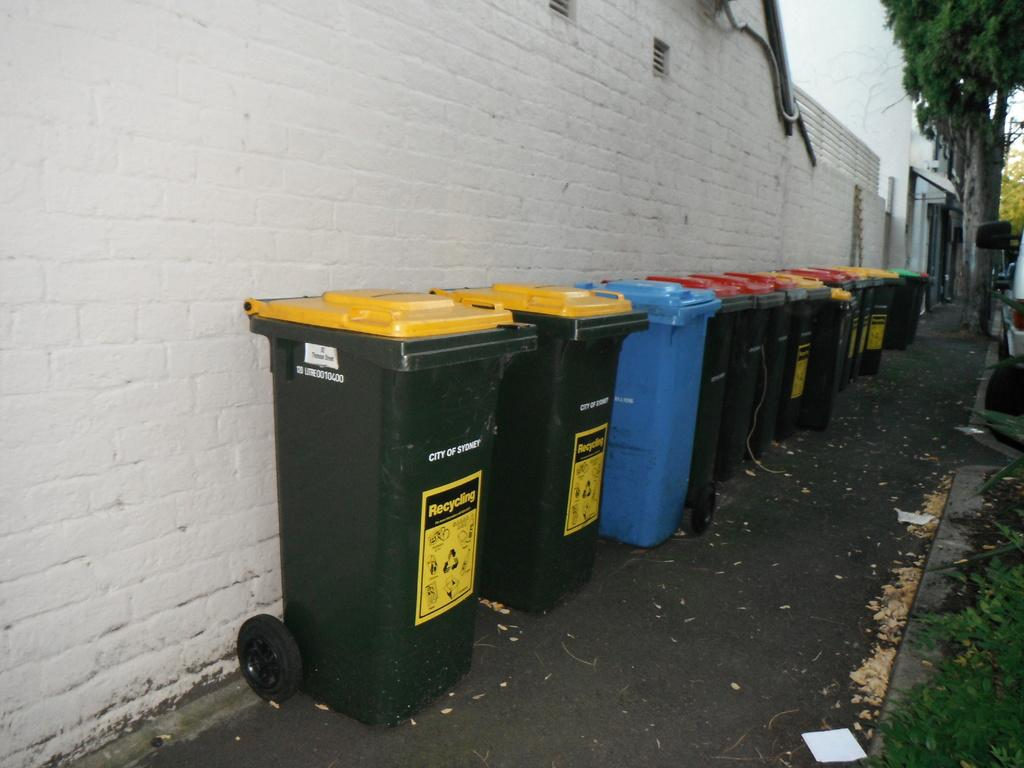<image>
Provide a brief description of the given image. alot of city of sydney recycling bins outside of a building 